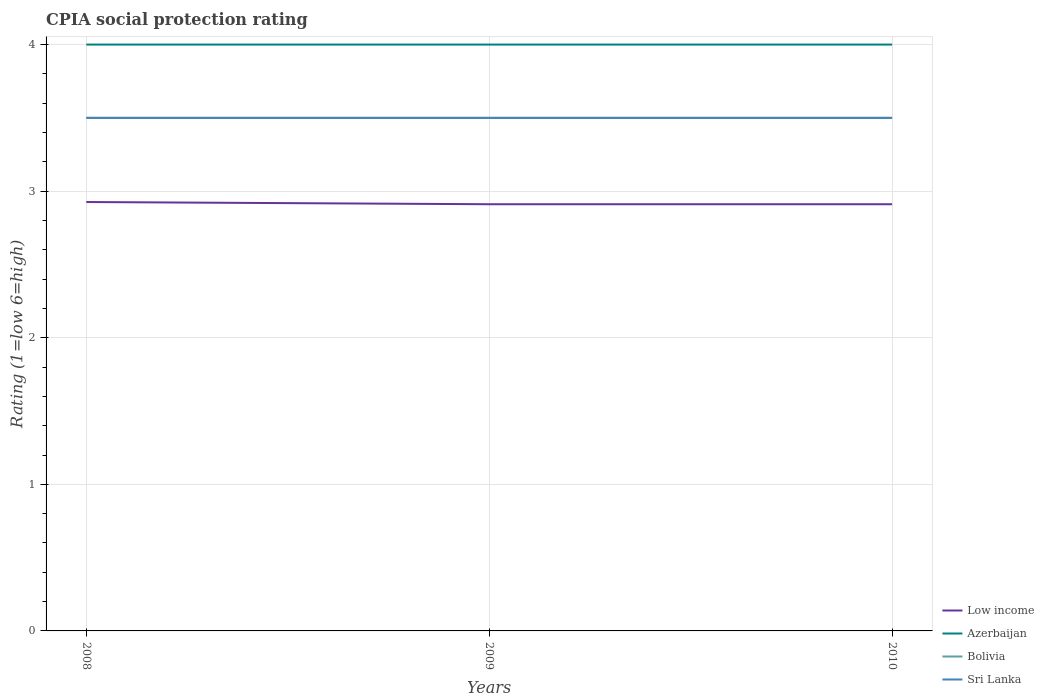How many different coloured lines are there?
Offer a very short reply. 4. Is the number of lines equal to the number of legend labels?
Your response must be concise. Yes. Across all years, what is the maximum CPIA rating in Low income?
Ensure brevity in your answer.  2.91. What is the difference between the highest and the lowest CPIA rating in Low income?
Keep it short and to the point. 1. Does the graph contain any zero values?
Offer a very short reply. No. Does the graph contain grids?
Your answer should be compact. Yes. How many legend labels are there?
Offer a terse response. 4. How are the legend labels stacked?
Offer a terse response. Vertical. What is the title of the graph?
Make the answer very short. CPIA social protection rating. Does "Uzbekistan" appear as one of the legend labels in the graph?
Provide a succinct answer. No. What is the label or title of the Y-axis?
Make the answer very short. Rating (1=low 6=high). What is the Rating (1=low 6=high) of Low income in 2008?
Make the answer very short. 2.93. What is the Rating (1=low 6=high) in Azerbaijan in 2008?
Your response must be concise. 4. What is the Rating (1=low 6=high) of Sri Lanka in 2008?
Ensure brevity in your answer.  3.5. What is the Rating (1=low 6=high) of Low income in 2009?
Your answer should be very brief. 2.91. What is the Rating (1=low 6=high) of Sri Lanka in 2009?
Provide a succinct answer. 3.5. What is the Rating (1=low 6=high) in Low income in 2010?
Keep it short and to the point. 2.91. What is the Rating (1=low 6=high) of Azerbaijan in 2010?
Your answer should be very brief. 4. Across all years, what is the maximum Rating (1=low 6=high) of Low income?
Your answer should be very brief. 2.93. Across all years, what is the maximum Rating (1=low 6=high) in Sri Lanka?
Your response must be concise. 3.5. Across all years, what is the minimum Rating (1=low 6=high) of Low income?
Give a very brief answer. 2.91. Across all years, what is the minimum Rating (1=low 6=high) of Sri Lanka?
Your response must be concise. 3.5. What is the total Rating (1=low 6=high) of Low income in the graph?
Your answer should be compact. 8.75. What is the total Rating (1=low 6=high) of Azerbaijan in the graph?
Ensure brevity in your answer.  12. What is the total Rating (1=low 6=high) of Bolivia in the graph?
Your answer should be compact. 10.5. What is the difference between the Rating (1=low 6=high) in Low income in 2008 and that in 2009?
Offer a terse response. 0.02. What is the difference between the Rating (1=low 6=high) in Azerbaijan in 2008 and that in 2009?
Your response must be concise. 0. What is the difference between the Rating (1=low 6=high) in Bolivia in 2008 and that in 2009?
Keep it short and to the point. 0. What is the difference between the Rating (1=low 6=high) of Sri Lanka in 2008 and that in 2009?
Make the answer very short. 0. What is the difference between the Rating (1=low 6=high) in Low income in 2008 and that in 2010?
Provide a short and direct response. 0.02. What is the difference between the Rating (1=low 6=high) in Azerbaijan in 2008 and that in 2010?
Your response must be concise. 0. What is the difference between the Rating (1=low 6=high) in Sri Lanka in 2008 and that in 2010?
Your response must be concise. 0. What is the difference between the Rating (1=low 6=high) of Low income in 2009 and that in 2010?
Make the answer very short. 0. What is the difference between the Rating (1=low 6=high) of Azerbaijan in 2009 and that in 2010?
Ensure brevity in your answer.  0. What is the difference between the Rating (1=low 6=high) in Bolivia in 2009 and that in 2010?
Ensure brevity in your answer.  0. What is the difference between the Rating (1=low 6=high) in Sri Lanka in 2009 and that in 2010?
Ensure brevity in your answer.  0. What is the difference between the Rating (1=low 6=high) in Low income in 2008 and the Rating (1=low 6=high) in Azerbaijan in 2009?
Make the answer very short. -1.07. What is the difference between the Rating (1=low 6=high) of Low income in 2008 and the Rating (1=low 6=high) of Bolivia in 2009?
Make the answer very short. -0.57. What is the difference between the Rating (1=low 6=high) of Low income in 2008 and the Rating (1=low 6=high) of Sri Lanka in 2009?
Your response must be concise. -0.57. What is the difference between the Rating (1=low 6=high) in Azerbaijan in 2008 and the Rating (1=low 6=high) in Bolivia in 2009?
Give a very brief answer. 0.5. What is the difference between the Rating (1=low 6=high) of Bolivia in 2008 and the Rating (1=low 6=high) of Sri Lanka in 2009?
Your answer should be compact. 0. What is the difference between the Rating (1=low 6=high) of Low income in 2008 and the Rating (1=low 6=high) of Azerbaijan in 2010?
Provide a succinct answer. -1.07. What is the difference between the Rating (1=low 6=high) in Low income in 2008 and the Rating (1=low 6=high) in Bolivia in 2010?
Your response must be concise. -0.57. What is the difference between the Rating (1=low 6=high) of Low income in 2008 and the Rating (1=low 6=high) of Sri Lanka in 2010?
Provide a short and direct response. -0.57. What is the difference between the Rating (1=low 6=high) in Azerbaijan in 2008 and the Rating (1=low 6=high) in Sri Lanka in 2010?
Your answer should be very brief. 0.5. What is the difference between the Rating (1=low 6=high) in Bolivia in 2008 and the Rating (1=low 6=high) in Sri Lanka in 2010?
Your answer should be very brief. 0. What is the difference between the Rating (1=low 6=high) in Low income in 2009 and the Rating (1=low 6=high) in Azerbaijan in 2010?
Offer a very short reply. -1.09. What is the difference between the Rating (1=low 6=high) of Low income in 2009 and the Rating (1=low 6=high) of Bolivia in 2010?
Provide a short and direct response. -0.59. What is the difference between the Rating (1=low 6=high) of Low income in 2009 and the Rating (1=low 6=high) of Sri Lanka in 2010?
Give a very brief answer. -0.59. What is the difference between the Rating (1=low 6=high) of Azerbaijan in 2009 and the Rating (1=low 6=high) of Bolivia in 2010?
Your response must be concise. 0.5. What is the difference between the Rating (1=low 6=high) of Azerbaijan in 2009 and the Rating (1=low 6=high) of Sri Lanka in 2010?
Your answer should be very brief. 0.5. What is the difference between the Rating (1=low 6=high) in Bolivia in 2009 and the Rating (1=low 6=high) in Sri Lanka in 2010?
Ensure brevity in your answer.  0. What is the average Rating (1=low 6=high) of Low income per year?
Ensure brevity in your answer.  2.92. What is the average Rating (1=low 6=high) in Azerbaijan per year?
Offer a terse response. 4. What is the average Rating (1=low 6=high) of Bolivia per year?
Your answer should be compact. 3.5. In the year 2008, what is the difference between the Rating (1=low 6=high) of Low income and Rating (1=low 6=high) of Azerbaijan?
Make the answer very short. -1.07. In the year 2008, what is the difference between the Rating (1=low 6=high) in Low income and Rating (1=low 6=high) in Bolivia?
Your response must be concise. -0.57. In the year 2008, what is the difference between the Rating (1=low 6=high) in Low income and Rating (1=low 6=high) in Sri Lanka?
Your answer should be compact. -0.57. In the year 2008, what is the difference between the Rating (1=low 6=high) of Azerbaijan and Rating (1=low 6=high) of Sri Lanka?
Make the answer very short. 0.5. In the year 2009, what is the difference between the Rating (1=low 6=high) of Low income and Rating (1=low 6=high) of Azerbaijan?
Provide a short and direct response. -1.09. In the year 2009, what is the difference between the Rating (1=low 6=high) of Low income and Rating (1=low 6=high) of Bolivia?
Offer a very short reply. -0.59. In the year 2009, what is the difference between the Rating (1=low 6=high) of Low income and Rating (1=low 6=high) of Sri Lanka?
Ensure brevity in your answer.  -0.59. In the year 2009, what is the difference between the Rating (1=low 6=high) of Azerbaijan and Rating (1=low 6=high) of Sri Lanka?
Your answer should be compact. 0.5. In the year 2010, what is the difference between the Rating (1=low 6=high) in Low income and Rating (1=low 6=high) in Azerbaijan?
Ensure brevity in your answer.  -1.09. In the year 2010, what is the difference between the Rating (1=low 6=high) in Low income and Rating (1=low 6=high) in Bolivia?
Make the answer very short. -0.59. In the year 2010, what is the difference between the Rating (1=low 6=high) of Low income and Rating (1=low 6=high) of Sri Lanka?
Provide a short and direct response. -0.59. What is the ratio of the Rating (1=low 6=high) of Low income in 2008 to that in 2009?
Give a very brief answer. 1.01. What is the ratio of the Rating (1=low 6=high) in Bolivia in 2008 to that in 2009?
Provide a succinct answer. 1. What is the ratio of the Rating (1=low 6=high) in Sri Lanka in 2008 to that in 2010?
Your answer should be compact. 1. What is the ratio of the Rating (1=low 6=high) of Azerbaijan in 2009 to that in 2010?
Ensure brevity in your answer.  1. What is the ratio of the Rating (1=low 6=high) of Sri Lanka in 2009 to that in 2010?
Your answer should be compact. 1. What is the difference between the highest and the second highest Rating (1=low 6=high) of Low income?
Offer a very short reply. 0.02. What is the difference between the highest and the lowest Rating (1=low 6=high) of Low income?
Ensure brevity in your answer.  0.02. What is the difference between the highest and the lowest Rating (1=low 6=high) of Azerbaijan?
Ensure brevity in your answer.  0. What is the difference between the highest and the lowest Rating (1=low 6=high) of Bolivia?
Your answer should be very brief. 0. 